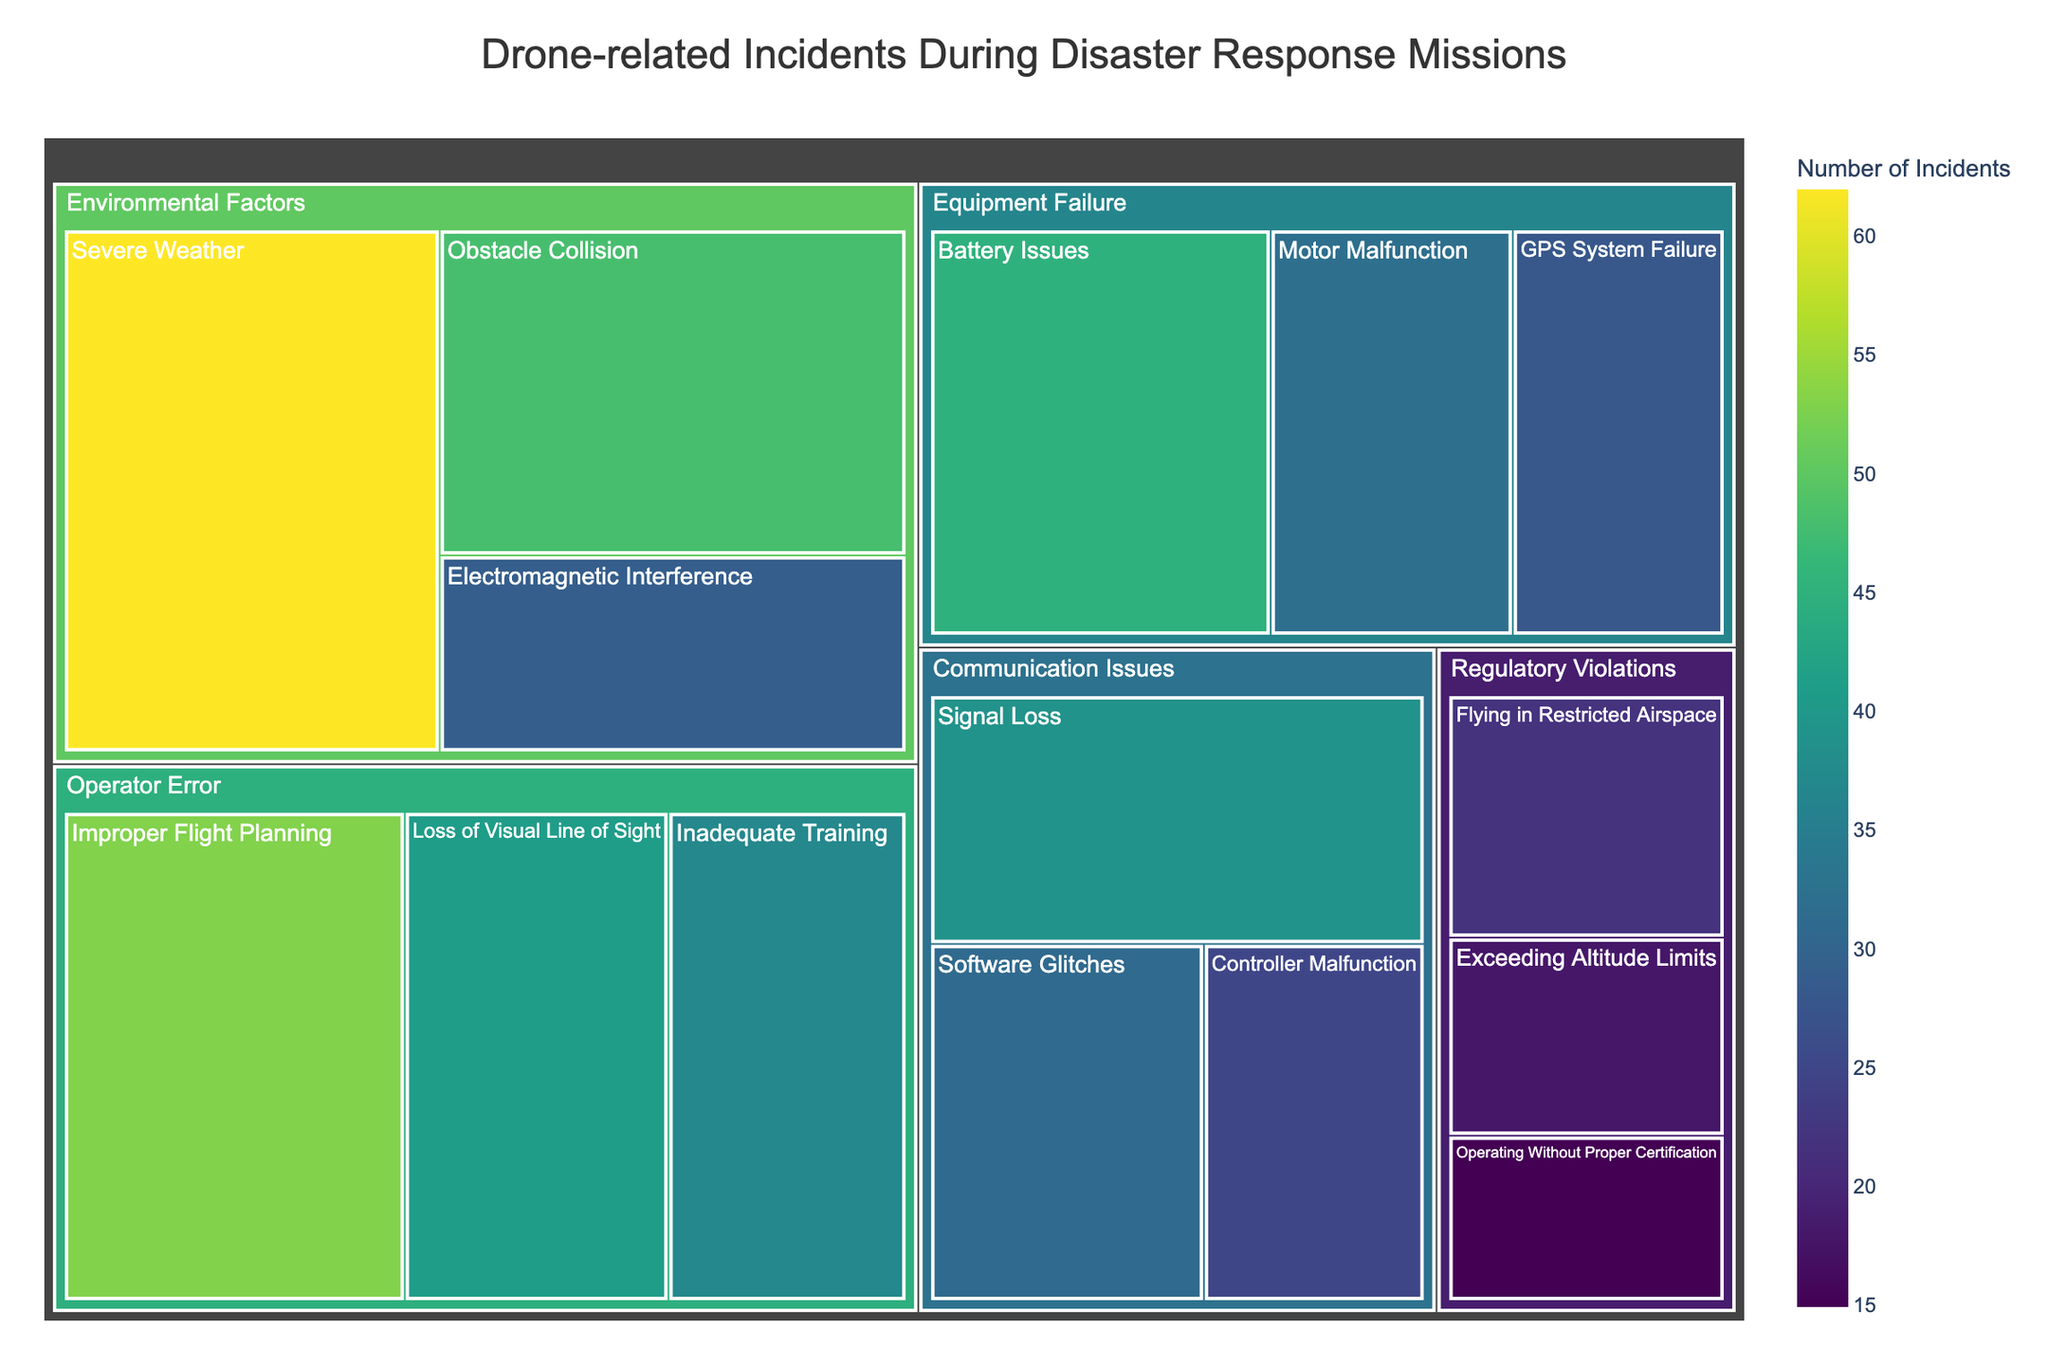What is the title of the treemap? Look at the top center of the figure where the title is displayed.
Answer: Drone-related Incidents During Disaster Response Missions Which subcategory under "Equipment Failure" has the highest number of incidents? Identify categories and the subcategories within them by looking at the labeled sections. Compare the values for each subcategory in "Equipment Failure."
Answer: Battery Issues How many incidents are accounted for by "Operator Error" as a whole? Sum the incident values of all subcategories under "Operator Error" (53 + 41 + 37).
Answer: 131 Which has fewer incidents: "Severe Weather" or "Improper Flight Planning"? Check the incident values for "Severe Weather" under Environmental Factors and "Improper Flight Planning" under Operator Error and compare them.
Answer: Improper Flight Planning Which subcategory has more incidents: "Obstacle Collision" or "GPS System Failure"? Look at the incident values for "Obstacle Collision" and "GPS System Failure" and compare them.
Answer: Obstacle Collision What is the difference between the number of incidents in "Flying in Restricted Airspace" and "Software Glitches"? Find the incident values for "Flying in Restricted Airspace" and "Software Glitches" and subtract the smaller from the larger (31 - 22).
Answer: 9 How many total incidents are there under "Communication Issues"? Sum the incident values of all subcategories under "Communication Issues" (39 + 25 + 31).
Answer: 95 Which environmental factor related subcategory has the least incidents? Identify the subcategories under "Environmental Factors" and compare their incident values to find the smallest.
Answer: Electromagnetic Interference Which category has the most total incidents? Sum the incident values for all subcategories within each category. Compare the total values to determine which is the largest.
Answer: Environmental Factors What is the ratio of incidents between "Battery Issues" and "Inadequate Training"? Find the incident values for "Battery Issues" and "Inadequate Training," then divide the former by the latter (45 ÷ 37).
Answer: Approximately 1.22 